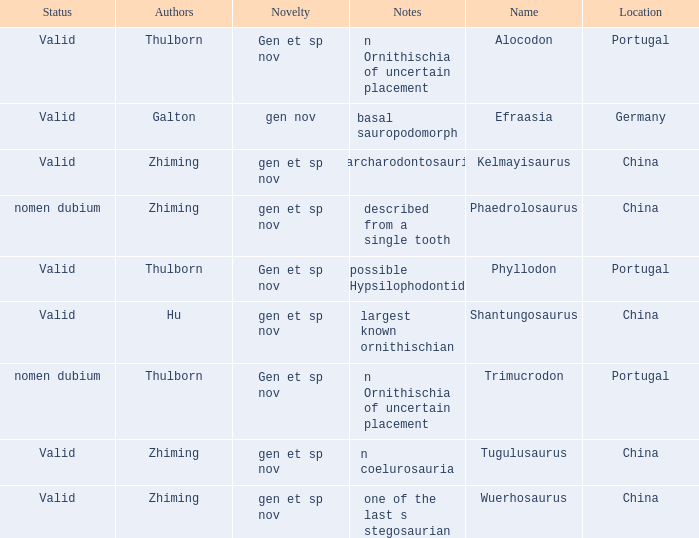What is the Name of the dinosaur that was discovered in the Location, China, and whose Notes are, "described from a single tooth"? Phaedrolosaurus. Help me parse the entirety of this table. {'header': ['Status', 'Authors', 'Novelty', 'Notes', 'Name', 'Location'], 'rows': [['Valid', 'Thulborn', 'Gen et sp nov', 'n Ornithischia of uncertain placement', 'Alocodon', 'Portugal'], ['Valid', 'Galton', 'gen nov', 'basal sauropodomorph', 'Efraasia', 'Germany'], ['Valid', 'Zhiming', 'gen et sp nov', 'carcharodontosaurid', 'Kelmayisaurus', 'China'], ['nomen dubium', 'Zhiming', 'gen et sp nov', 'described from a single tooth', 'Phaedrolosaurus', 'China'], ['Valid', 'Thulborn', 'Gen et sp nov', 'possible Hypsilophodontid', 'Phyllodon', 'Portugal'], ['Valid', 'Hu', 'gen et sp nov', 'largest known ornithischian', 'Shantungosaurus', 'China'], ['nomen dubium', 'Thulborn', 'Gen et sp nov', 'n Ornithischia of uncertain placement', 'Trimucrodon', 'Portugal'], ['Valid', 'Zhiming', 'gen et sp nov', 'n coelurosauria', 'Tugulusaurus', 'China'], ['Valid', 'Zhiming', 'gen et sp nov', 'one of the last s stegosaurian', 'Wuerhosaurus', 'China']]} 